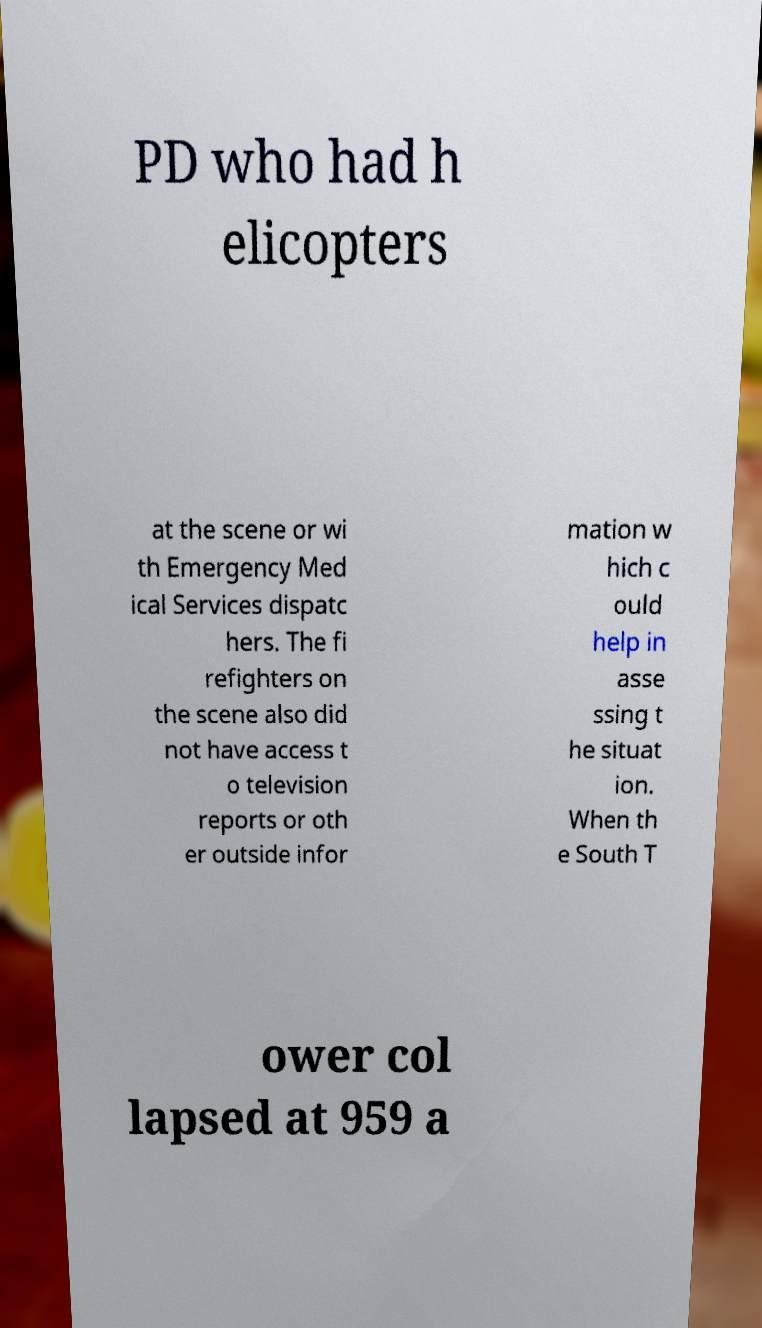Could you extract and type out the text from this image? PD who had h elicopters at the scene or wi th Emergency Med ical Services dispatc hers. The fi refighters on the scene also did not have access t o television reports or oth er outside infor mation w hich c ould help in asse ssing t he situat ion. When th e South T ower col lapsed at 959 a 